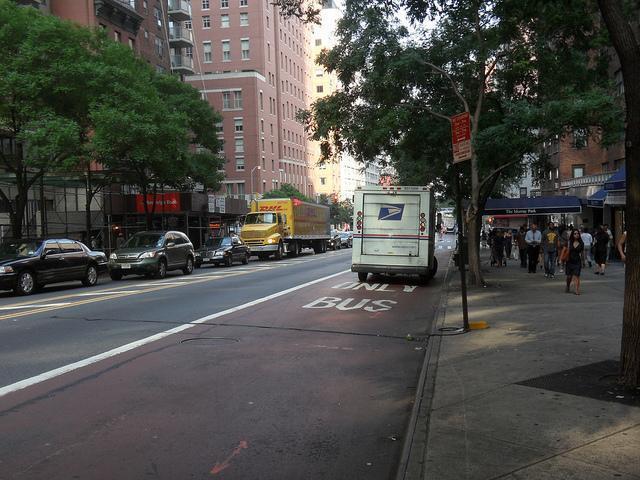How many buses are pink?
Give a very brief answer. 0. How many cars are in the photo?
Give a very brief answer. 2. How many trucks are there?
Give a very brief answer. 2. How many zebras are looking around?
Give a very brief answer. 0. 